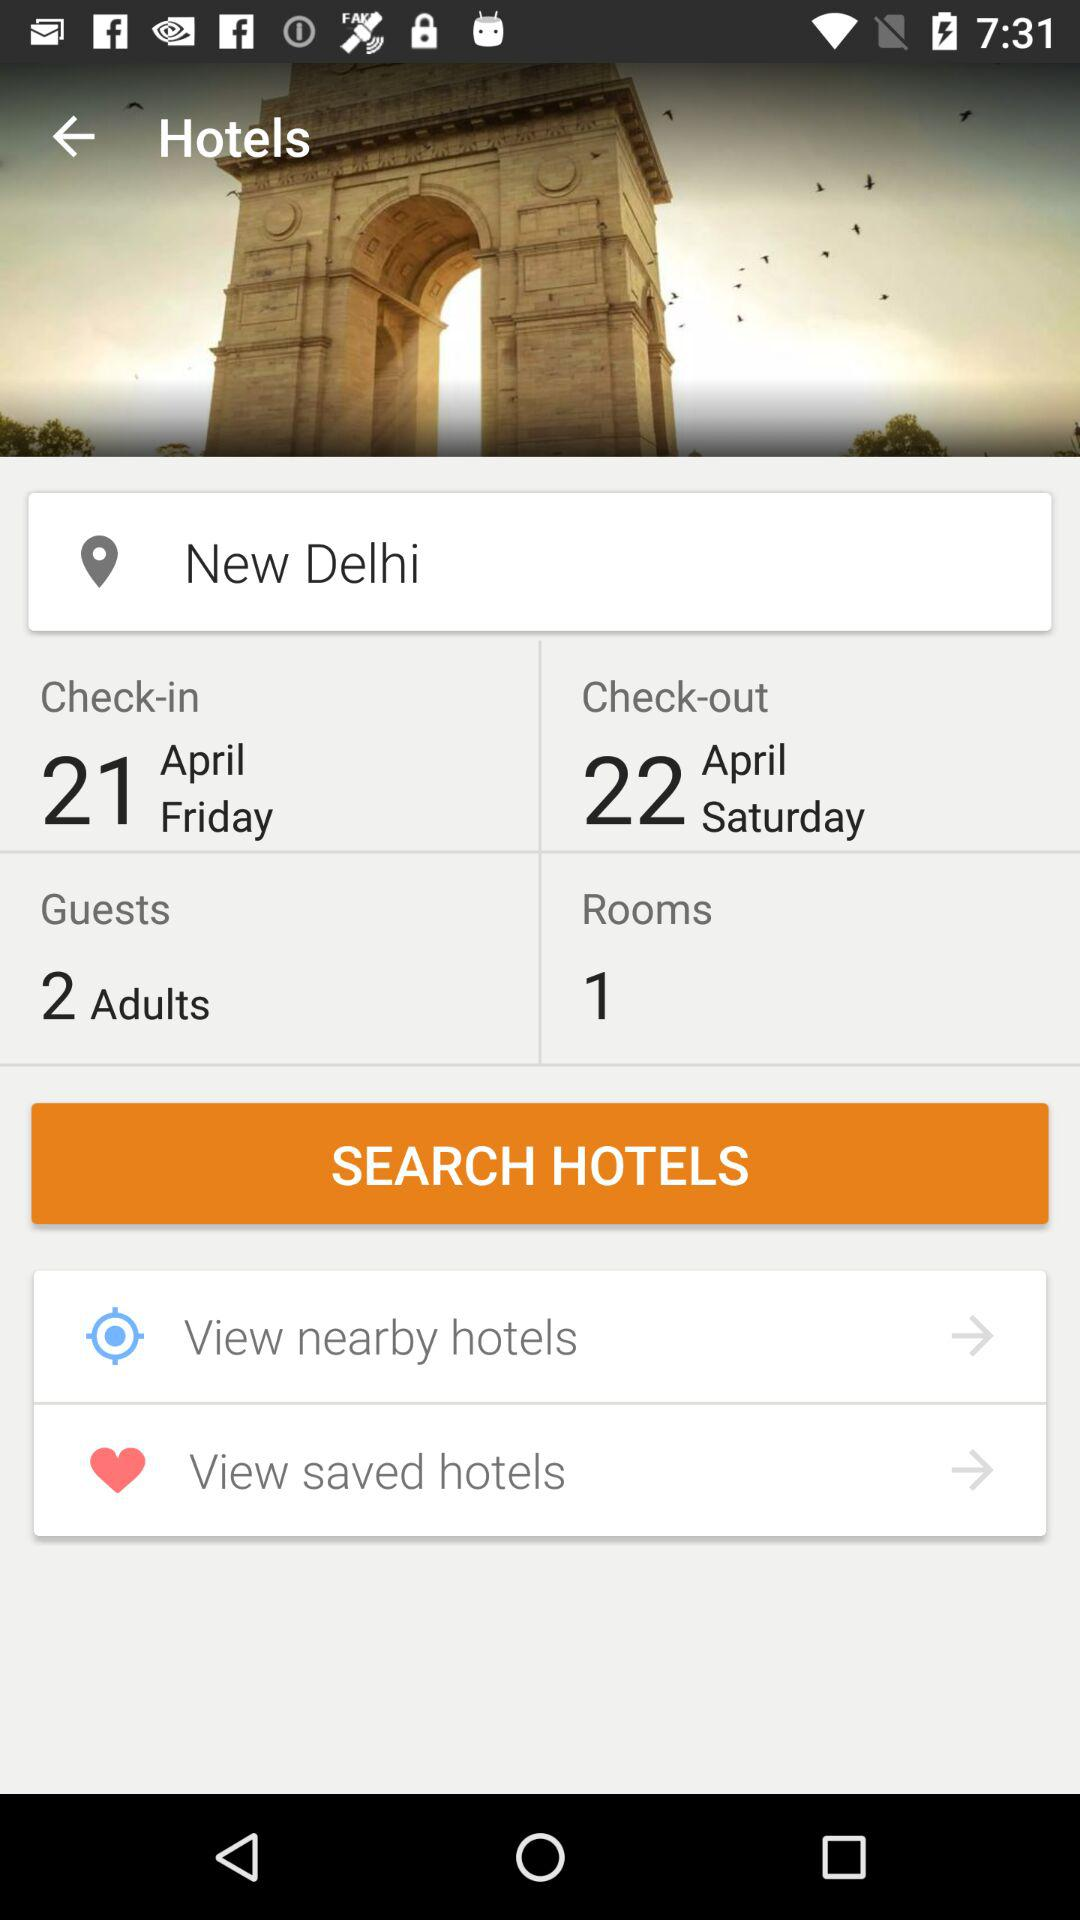What hotels are nearby?
When the provided information is insufficient, respond with <no answer>. <no answer> 